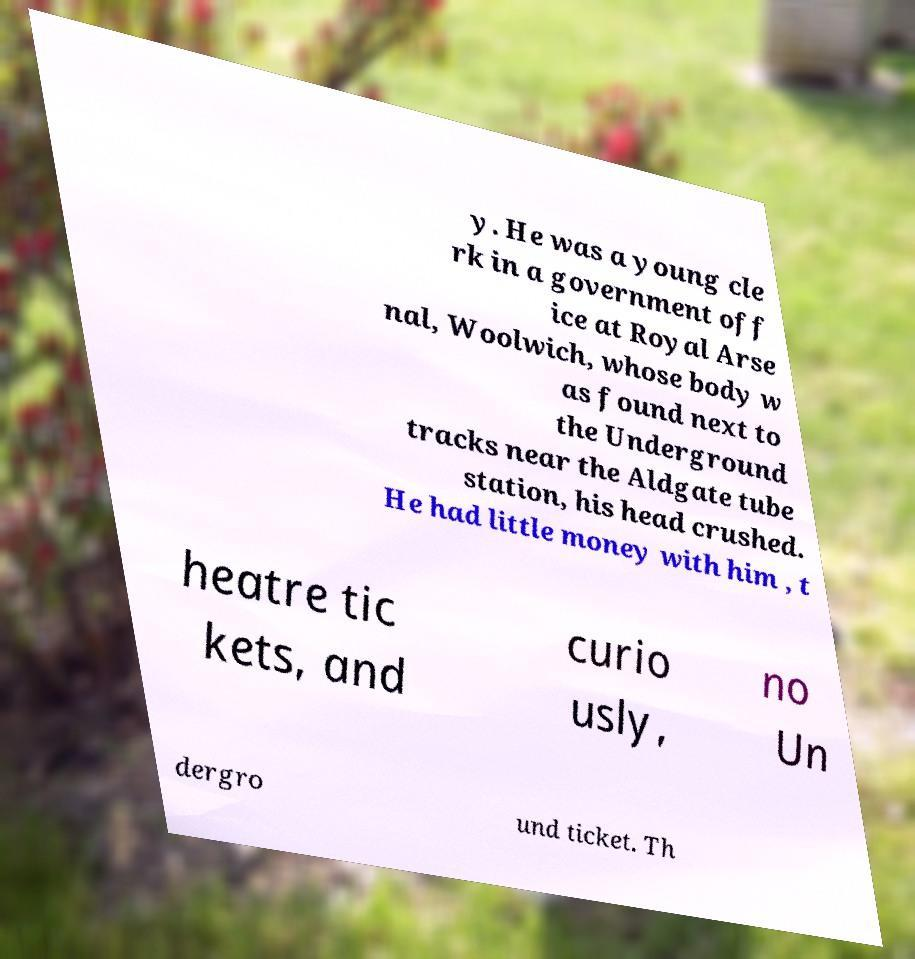Please identify and transcribe the text found in this image. y. He was a young cle rk in a government off ice at Royal Arse nal, Woolwich, whose body w as found next to the Underground tracks near the Aldgate tube station, his head crushed. He had little money with him , t heatre tic kets, and curio usly, no Un dergro und ticket. Th 